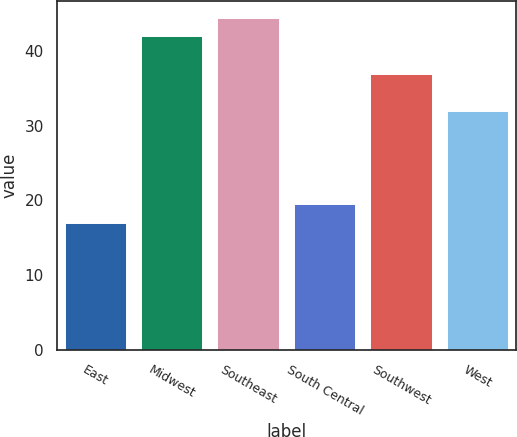Convert chart. <chart><loc_0><loc_0><loc_500><loc_500><bar_chart><fcel>East<fcel>Midwest<fcel>Southeast<fcel>South Central<fcel>Southwest<fcel>West<nl><fcel>17<fcel>42<fcel>44.5<fcel>19.5<fcel>37<fcel>32<nl></chart> 